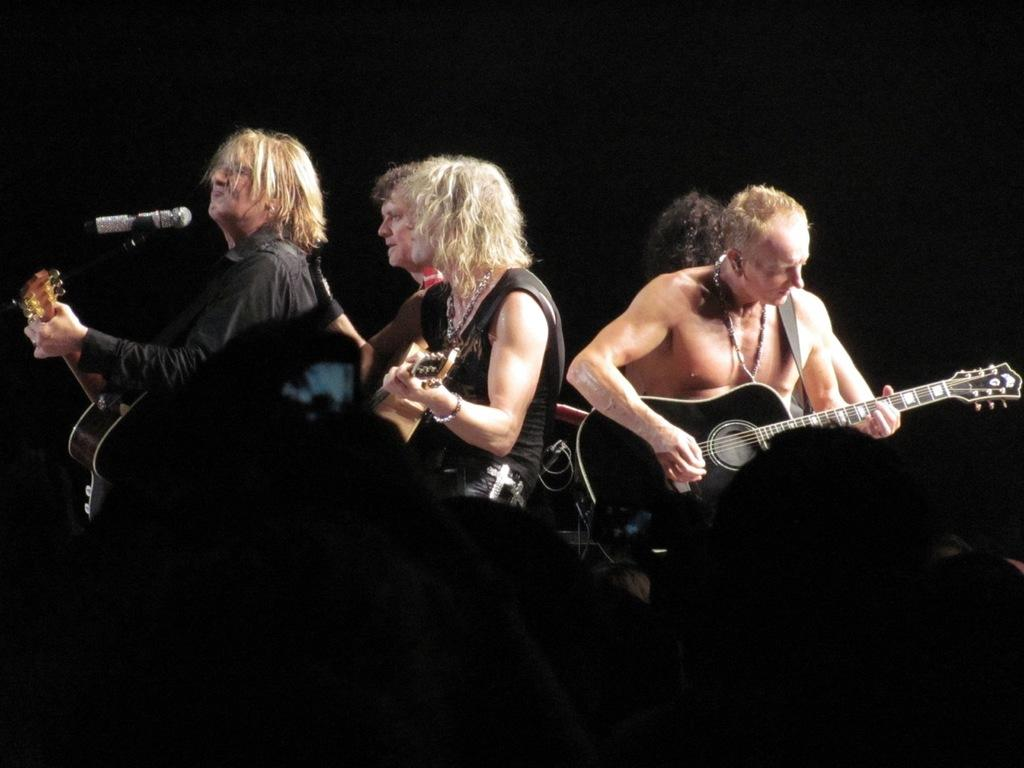How many people are in the image? There are five persons in the image. What are some of the persons holding in the image? Three of the persons are holding guitars. Can you describe the position of one person in relation to a specific object? One person is in front of a microphone. How many rabbits are visible in the image? There are no rabbits present in the image. What type of songs are the persons singing in the image? The image does not provide any information about the songs being sung, as it only shows the persons holding guitars and standing near a microphone. 